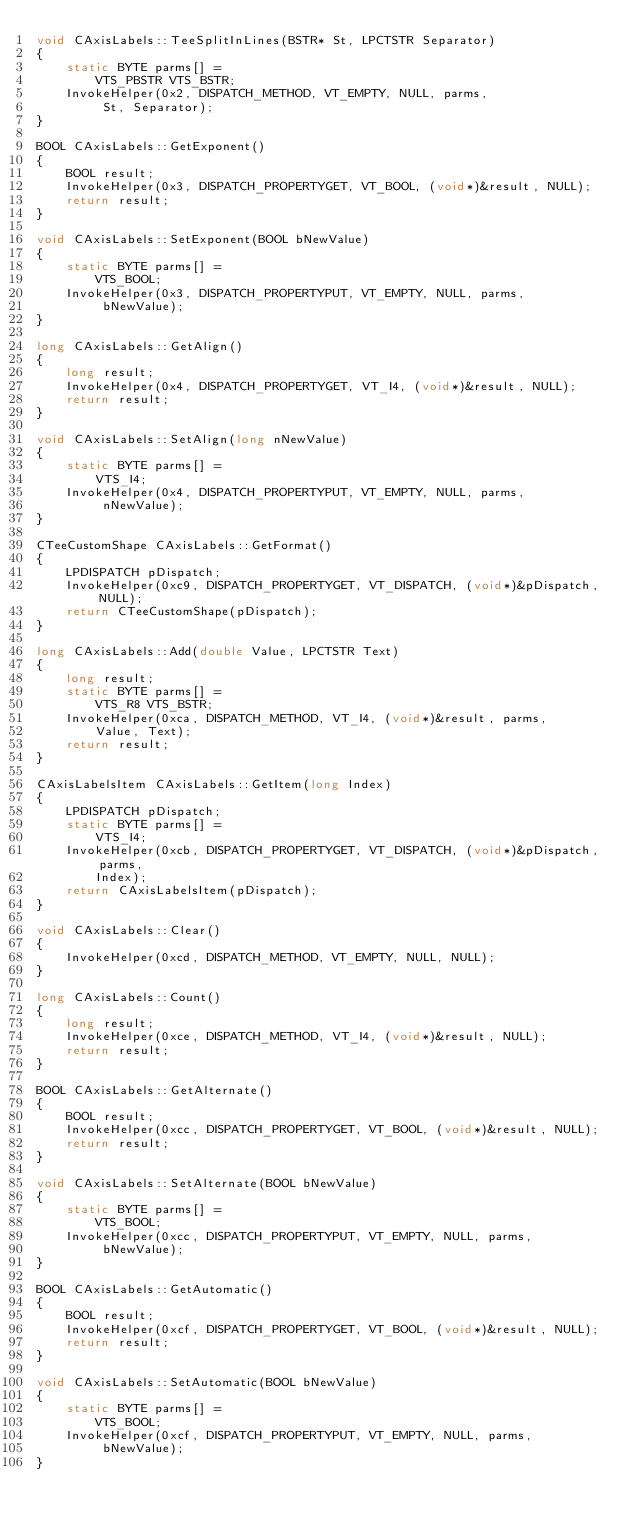<code> <loc_0><loc_0><loc_500><loc_500><_C++_>void CAxisLabels::TeeSplitInLines(BSTR* St, LPCTSTR Separator)
{
	static BYTE parms[] =
		VTS_PBSTR VTS_BSTR;
	InvokeHelper(0x2, DISPATCH_METHOD, VT_EMPTY, NULL, parms,
		 St, Separator);
}

BOOL CAxisLabels::GetExponent()
{
	BOOL result;
	InvokeHelper(0x3, DISPATCH_PROPERTYGET, VT_BOOL, (void*)&result, NULL);
	return result;
}

void CAxisLabels::SetExponent(BOOL bNewValue)
{
	static BYTE parms[] =
		VTS_BOOL;
	InvokeHelper(0x3, DISPATCH_PROPERTYPUT, VT_EMPTY, NULL, parms,
		 bNewValue);
}

long CAxisLabels::GetAlign()
{
	long result;
	InvokeHelper(0x4, DISPATCH_PROPERTYGET, VT_I4, (void*)&result, NULL);
	return result;
}

void CAxisLabels::SetAlign(long nNewValue)
{
	static BYTE parms[] =
		VTS_I4;
	InvokeHelper(0x4, DISPATCH_PROPERTYPUT, VT_EMPTY, NULL, parms,
		 nNewValue);
}

CTeeCustomShape CAxisLabels::GetFormat()
{
	LPDISPATCH pDispatch;
	InvokeHelper(0xc9, DISPATCH_PROPERTYGET, VT_DISPATCH, (void*)&pDispatch, NULL);
	return CTeeCustomShape(pDispatch);
}

long CAxisLabels::Add(double Value, LPCTSTR Text)
{
	long result;
	static BYTE parms[] =
		VTS_R8 VTS_BSTR;
	InvokeHelper(0xca, DISPATCH_METHOD, VT_I4, (void*)&result, parms,
		Value, Text);
	return result;
}

CAxisLabelsItem CAxisLabels::GetItem(long Index)
{
	LPDISPATCH pDispatch;
	static BYTE parms[] =
		VTS_I4;
	InvokeHelper(0xcb, DISPATCH_PROPERTYGET, VT_DISPATCH, (void*)&pDispatch, parms,
		Index);
	return CAxisLabelsItem(pDispatch);
}

void CAxisLabels::Clear()
{
	InvokeHelper(0xcd, DISPATCH_METHOD, VT_EMPTY, NULL, NULL);
}

long CAxisLabels::Count()
{
	long result;
	InvokeHelper(0xce, DISPATCH_METHOD, VT_I4, (void*)&result, NULL);
	return result;
}

BOOL CAxisLabels::GetAlternate()
{
	BOOL result;
	InvokeHelper(0xcc, DISPATCH_PROPERTYGET, VT_BOOL, (void*)&result, NULL);
	return result;
}

void CAxisLabels::SetAlternate(BOOL bNewValue)
{
	static BYTE parms[] =
		VTS_BOOL;
	InvokeHelper(0xcc, DISPATCH_PROPERTYPUT, VT_EMPTY, NULL, parms,
		 bNewValue);
}

BOOL CAxisLabels::GetAutomatic()
{
	BOOL result;
	InvokeHelper(0xcf, DISPATCH_PROPERTYGET, VT_BOOL, (void*)&result, NULL);
	return result;
}

void CAxisLabels::SetAutomatic(BOOL bNewValue)
{
	static BYTE parms[] =
		VTS_BOOL;
	InvokeHelper(0xcf, DISPATCH_PROPERTYPUT, VT_EMPTY, NULL, parms,
		 bNewValue);
}
</code> 